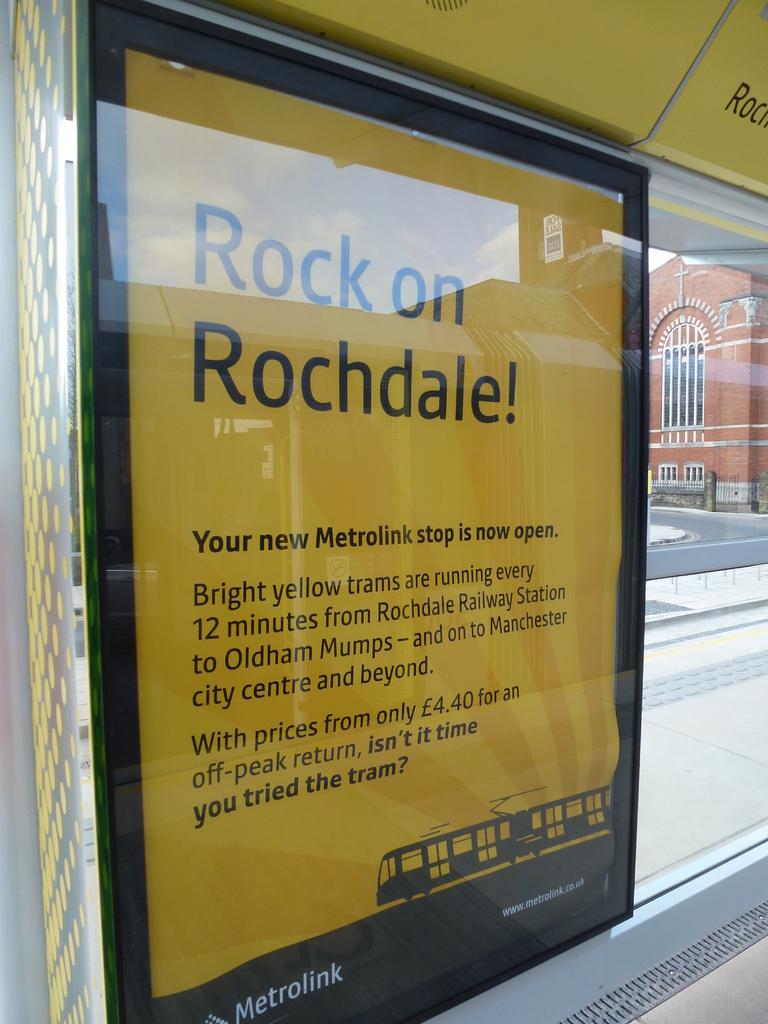What company is on the sign?
Your response must be concise. Metrolink. What information in the picture?
Keep it short and to the point. Metrolink. 